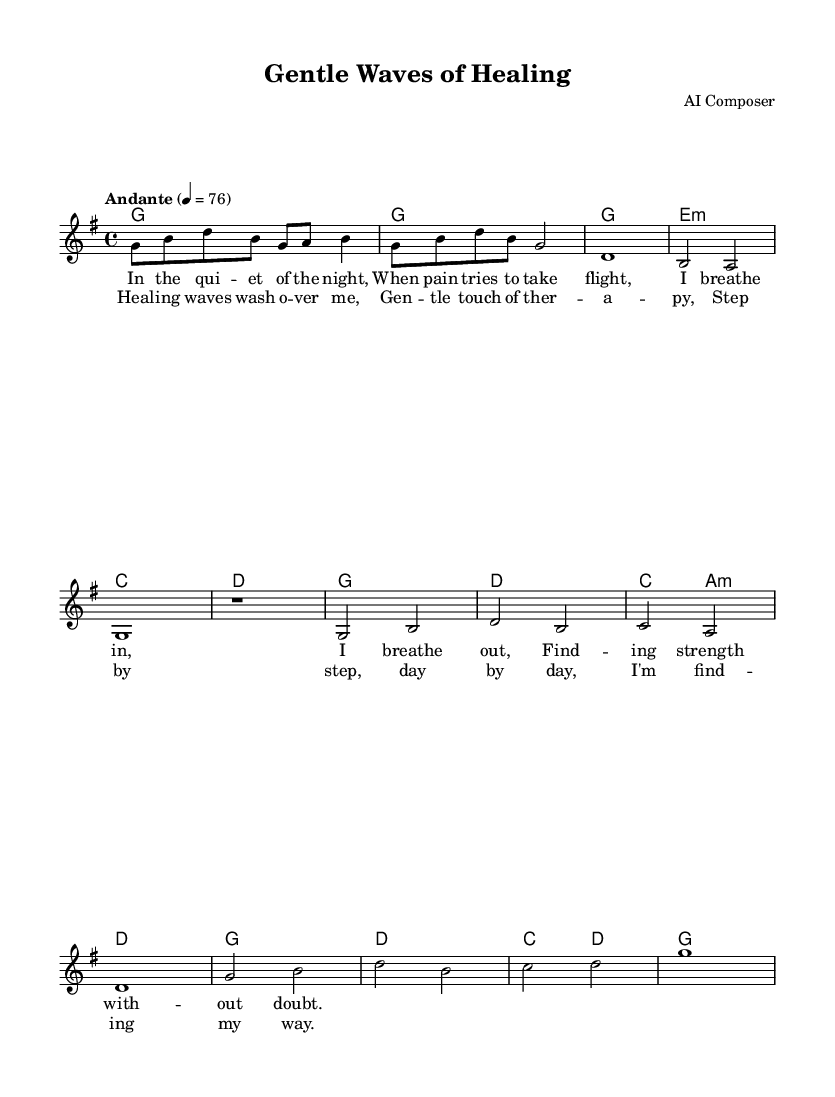What is the key signature of this music? The key signature is G major, which has one sharp (F#). This can be identified by looking at the key signature section at the beginning of the score.
Answer: G major What is the time signature of this music? The time signature is 4/4, which indicates there are four beats per measure. This can be found at the beginning of the score, which shows the time signature right after the key signature.
Answer: 4/4 What is the tempo marking for this piece? The tempo marking is Andante, meaning a moderately slow pace, typically around 76 beats per minute. The tempo indication is stated clearly above the staff, guiding the performance speed.
Answer: Andante How many measures are there in the verse section? There are four measures in the verse section. Counting carefully from the start of the verse until it transitions to the chorus, you can confirm the number of measures.
Answer: Four What instruments are indicated in the score? The score contains a staff for a lead voice and chord names for harmonies. By looking at the format of the layout, it's evident that the voice is the primary instrument with chord indications alongside.
Answer: Voice and chords What lyrical theme does this song focus on? The lyrical theme focuses on healing and self-care, as indicated by phrases such as "healing waves" and "gentle touch of therapy" in the lyrics. This can be inferred from the content of the lyrics provided in the score.
Answer: Healing and self-care Which chords are used in the chorus? The chords used in the chorus are G, D, C, and A minor. These chords can be identified by looking at the chord names indicated above the melody during the chorus section.
Answer: G, D, C, A minor 